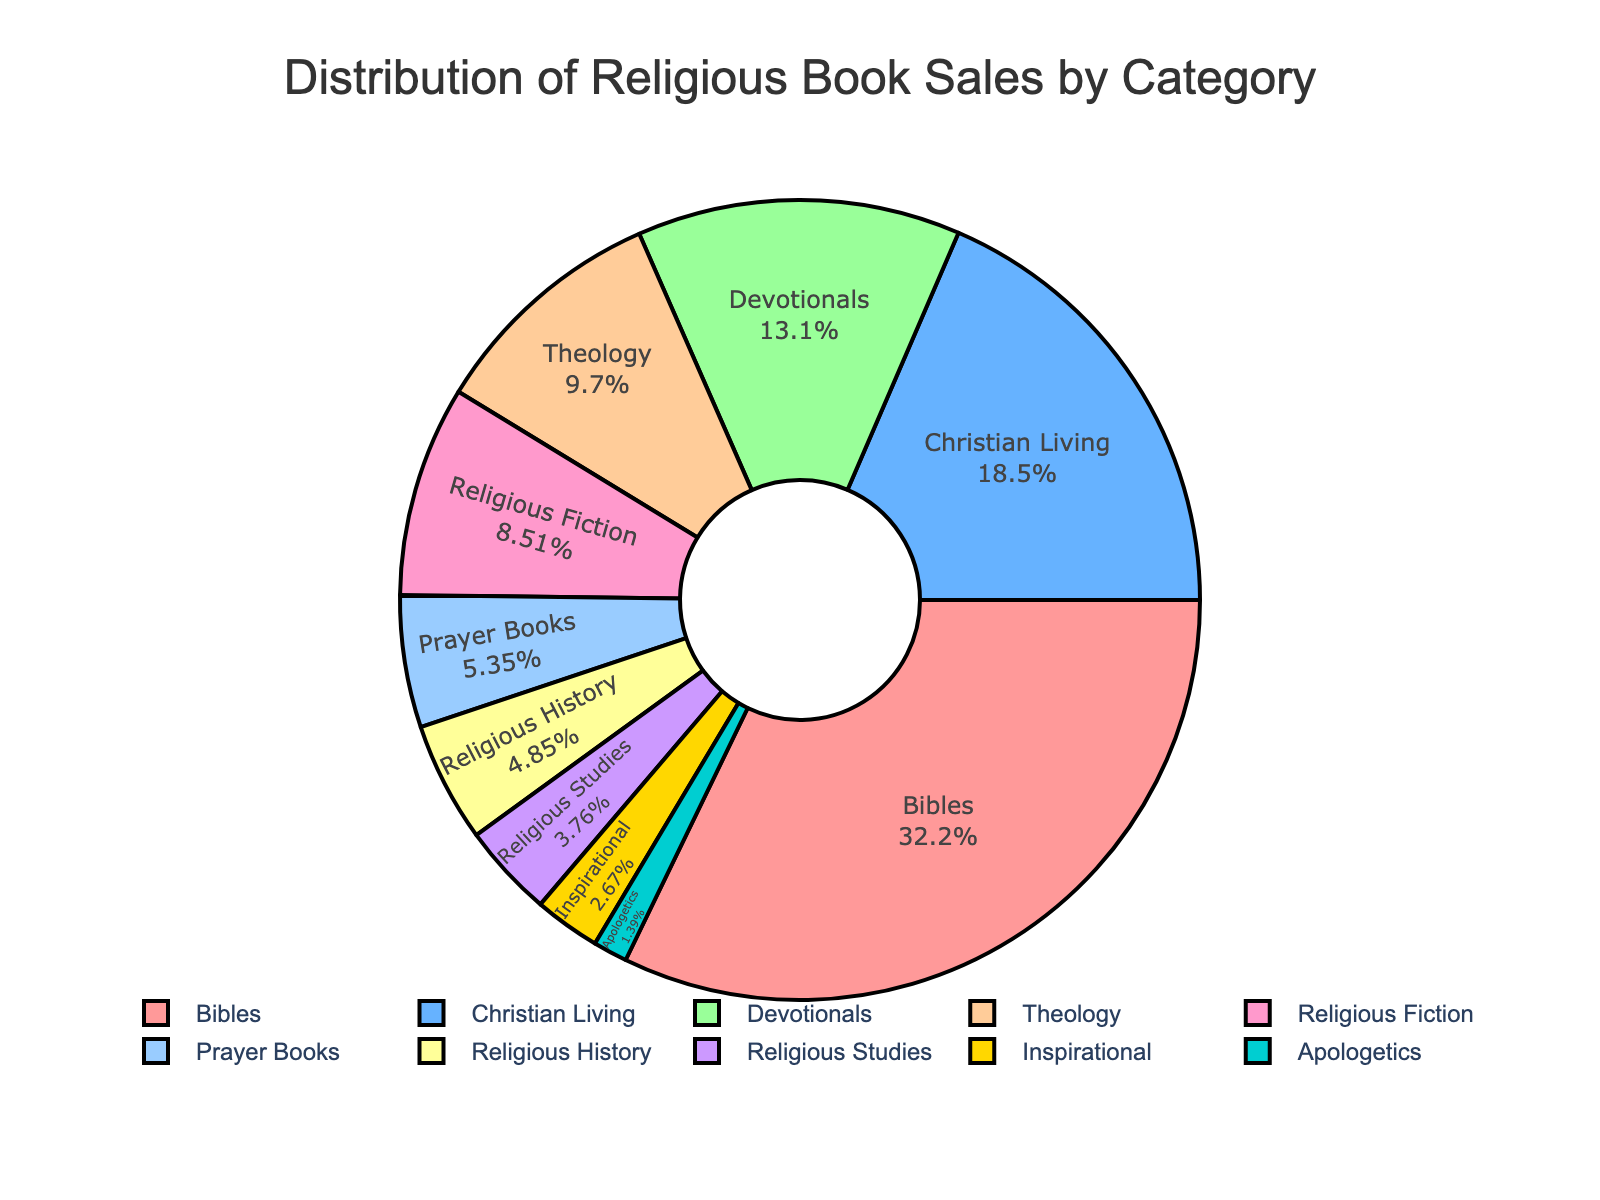What is the category with the highest percentage of sales? To determine which category has the highest percentage of sales, look at the pie chart segments and identify the largest one. The category with the largest segment is 'Bibles' at 32.5%.
Answer: Bibles Which category has the second-largest percentage of sales? Identify the second-largest segment in the pie chart. The 'Christian Living' category comes second with 18.7%.
Answer: Christian Living What is the combined percentage of 'Prayer Books' and 'Religious Fiction' sales? To find the combined percentage, add the 'Prayer Books' percentage (5.4%) with 'Religious Fiction' percentage (8.6%). The total is 5.4 + 8.6 = 14.
Answer: 14% What is the percentage difference between 'Theology' and 'Devotionals'? Subtract the percentage of 'Theology' (9.8%) from 'Devotionals' (13.2%). The difference is 13.2 - 9.8 = 3.4%.
Answer: 3.4% Which category represents the smallest percentage of sales? The segment with the smallest size in the pie chart represents the 'Apologetics' category at 1.4%.
Answer: Apologetics How many categories have a percentage of sales below 10%? Count the segments that represent percentages below 10% ("Theology", "Religious Fiction", "Prayer Books", "Religious History", "Religious Studies", "Inspirational", "Apologetics"). There are 7 segments.
Answer: 7 What is the total percentage of sales for all categories combined? The pie chart represents the distribution of all sales, summing up to 100%.
Answer: 100% How much larger is the 'Bibles' category compared to the 'Inspirational' category? Subtract the percentage of 'Inspirational' (2.7%) from 'Bibles' (32.5%). The difference is 32.5 - 2.7 = 29.8%.
Answer: 29.8% What is the average percentage of sales for the categories 'Bibles', 'Christian Living', and 'Devotionals'? Add the percentages of 'Bibles' (32.5%), 'Christian Living' (18.7%), and 'Devotionals' (13.2%) and divide by 3. The average is (32.5 + 18.7 + 13.2) / 3 = 21.467%.
Answer: 21.47% 